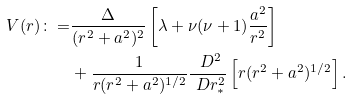<formula> <loc_0><loc_0><loc_500><loc_500>V ( r ) \colon = & \frac { \Delta } { ( r ^ { 2 } + a ^ { 2 } ) ^ { 2 } } \left [ \lambda + \nu ( \nu + 1 ) \frac { a ^ { 2 } } { r ^ { 2 } } \right ] \\ & + \frac { 1 } { r ( r ^ { 2 } + a ^ { 2 } ) ^ { 1 / 2 } } \frac { \ D ^ { 2 } } { \ D r _ { * } ^ { 2 } } \left [ r ( r ^ { 2 } + a ^ { 2 } ) ^ { 1 / 2 } \right ] .</formula> 